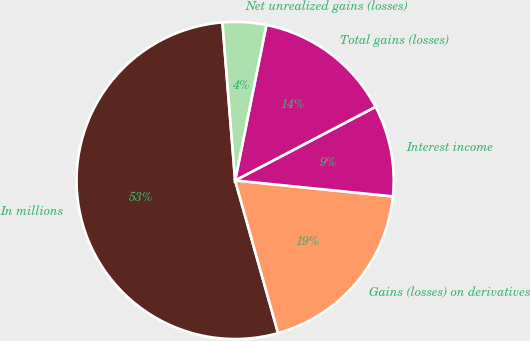Convert chart to OTSL. <chart><loc_0><loc_0><loc_500><loc_500><pie_chart><fcel>In millions<fcel>Gains (losses) on derivatives<fcel>Interest income<fcel>Total gains (losses)<fcel>Net unrealized gains (losses)<nl><fcel>53.09%<fcel>19.03%<fcel>9.29%<fcel>14.16%<fcel>4.43%<nl></chart> 